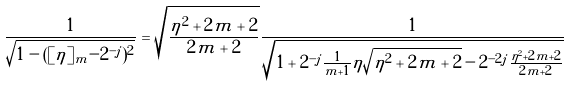Convert formula to latex. <formula><loc_0><loc_0><loc_500><loc_500>\frac { 1 } { \sqrt { 1 - ( [ \eta ] _ { m } - 2 ^ { - j } ) ^ { 2 } } } = \sqrt { \frac { \eta ^ { 2 } + 2 m + 2 } { 2 m + 2 } } \frac { 1 } { \sqrt { 1 + 2 ^ { - j } \frac { 1 } { m + 1 } \eta \sqrt { \eta ^ { 2 } + 2 m + 2 } - 2 ^ { - 2 j } \frac { \eta ^ { 2 } + 2 m + 2 } { 2 m + 2 } } }</formula> 